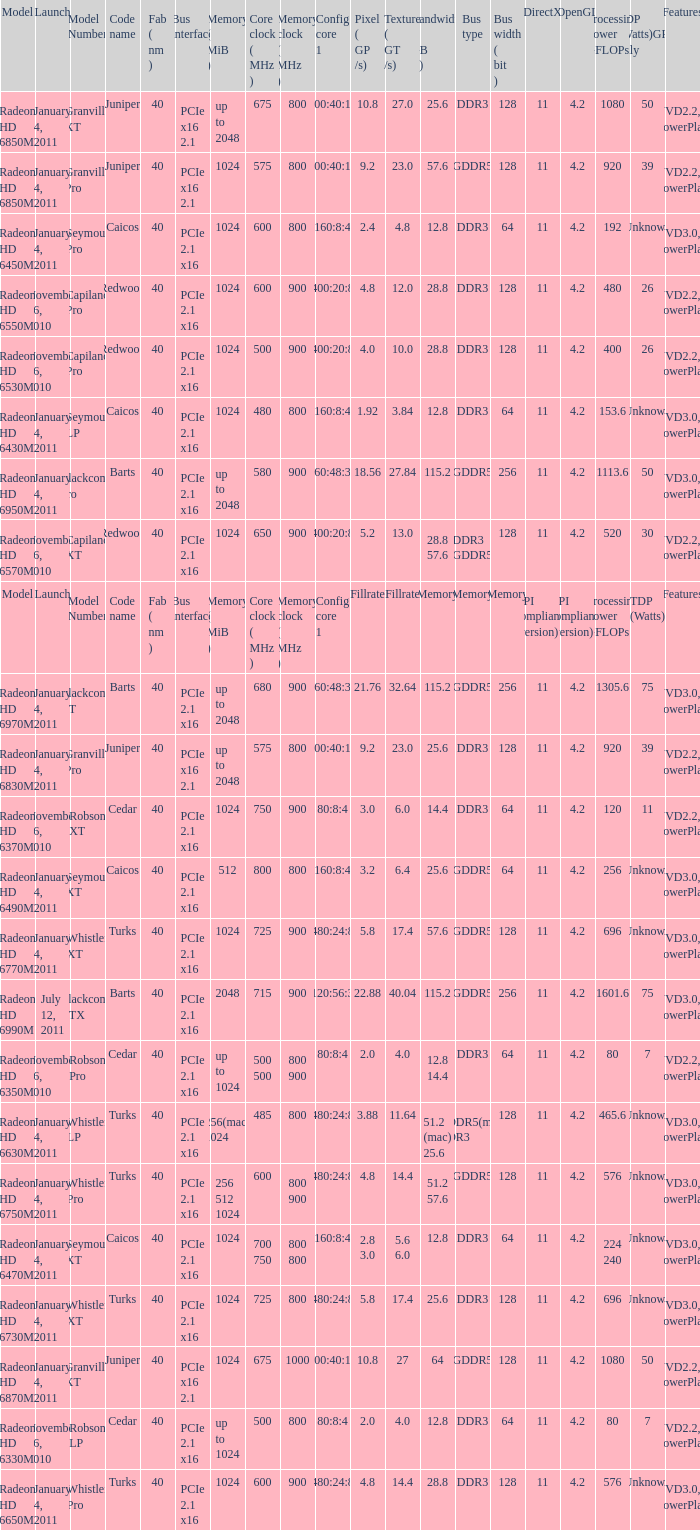What is the value for congi core 1 if the code name is Redwood and core clock(mhz) is 500? 400:20:8. 